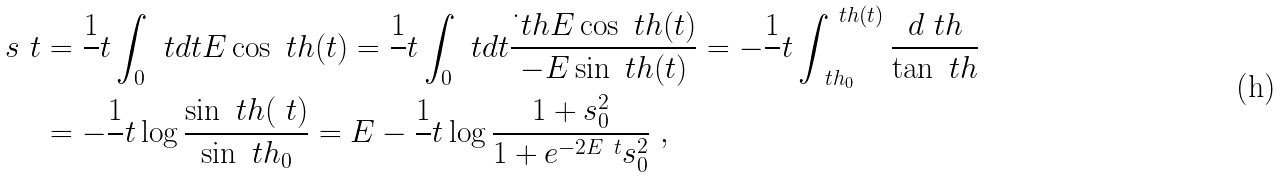<formula> <loc_0><loc_0><loc_500><loc_500>\ s _ { \ } t & = \frac { 1 } { \ } t \int _ { 0 } ^ { \ } t d t E \cos \ t h ( t ) = \frac { 1 } { \ } t \int _ { 0 } ^ { \ } t d t \frac { \dot { \ } t h E \cos \ t h ( t ) } { - E \sin \ t h ( t ) } = - \frac { 1 } { \ } t \int _ { \ t h _ { 0 } } ^ { \ t h ( t ) } \frac { d \ t h } { \tan \ t h } \\ & = - \frac { 1 } { \ } t \log \frac { \sin \ t h ( \ t ) } { \sin \ t h _ { 0 } } = E - \frac { 1 } { \ } t \log \frac { 1 + s ^ { 2 } _ { 0 } } { 1 + e ^ { - 2 E \ t } s ^ { 2 } _ { 0 } } \ ,</formula> 